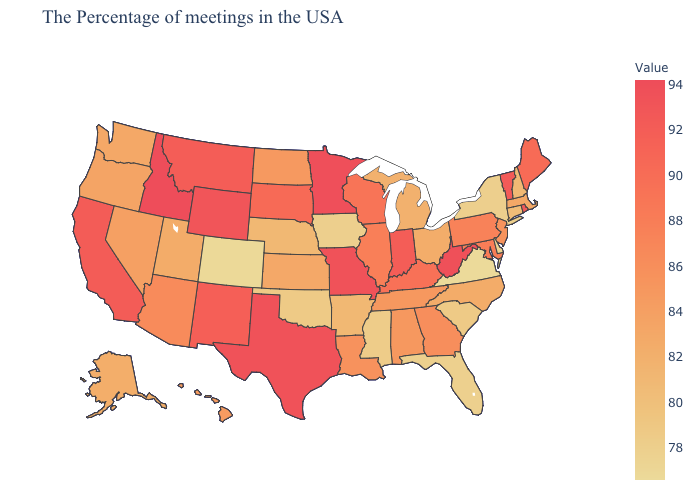Which states have the highest value in the USA?
Write a very short answer. Idaho. Which states have the lowest value in the USA?
Short answer required. Virginia. Does Indiana have the lowest value in the MidWest?
Give a very brief answer. No. Does the map have missing data?
Short answer required. No. Among the states that border Maine , which have the highest value?
Short answer required. New Hampshire. Which states have the lowest value in the USA?
Give a very brief answer. Virginia. 